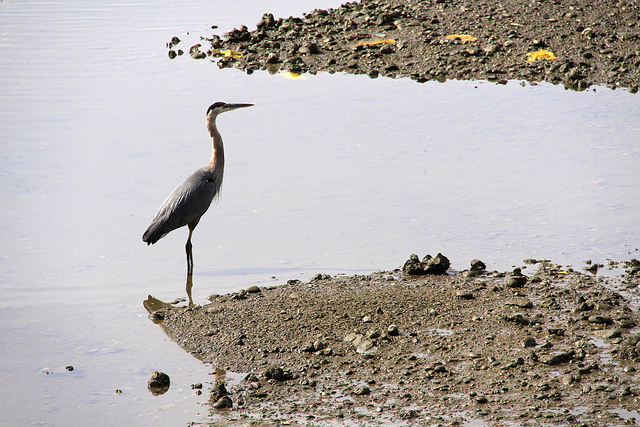<image>Why is one of the birds standing still in field? It is unknown why one of the birds is standing still in the field. It could be watching, resting, or looking for food. Why is one of the birds standing still in field? I don't know why one of the birds is standing still in the field. It could be resting, waiting, or looking for food. 